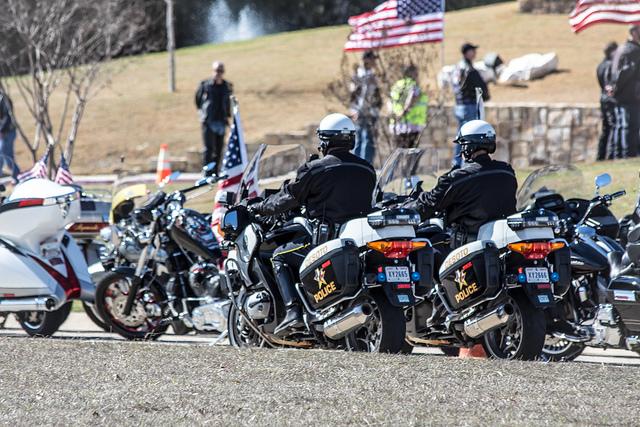What type of transportation are the police using?
Keep it brief. Motorcycles. What kind of people have gathered?
Concise answer only. Police. Who are these people?
Quick response, please. Police. How many different numbers do you see?
Quick response, please. 0. What surface to the bikes sit atop?
Answer briefly. Road. 